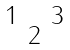Convert formula to latex. <formula><loc_0><loc_0><loc_500><loc_500>\begin{smallmatrix} & & & \\ 1 & & 3 & \\ & 2 & & \\ & & & \end{smallmatrix}</formula> 